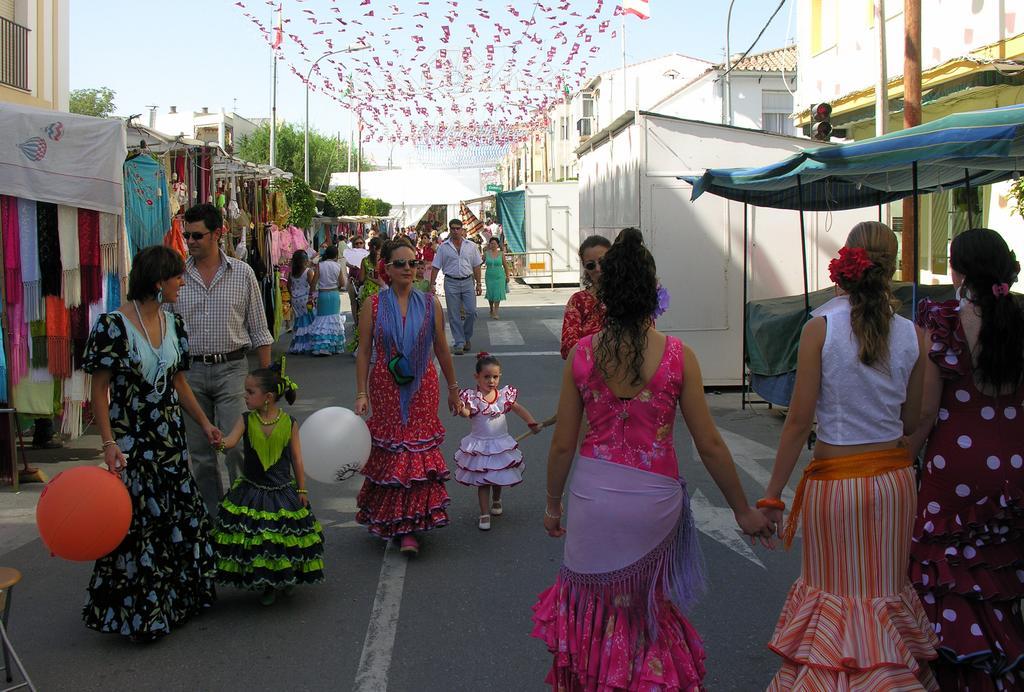Please provide a concise description of this image. In this image we can see the buildings, two sheds, some tents, some shops, some clothes hanged in the shops, some objects in the shops, some objects on the ground, one stool on the bottom left side corner of the image, some people are walking on the road, some people are standing, some people are holding objects, two balloons, few people holding children's hands, some poles, few lights with poles, two flags with poles, some wires, some objects looks like small flags attached to the wires at the top of the image, some trees in the background and at the top there is the sky. 